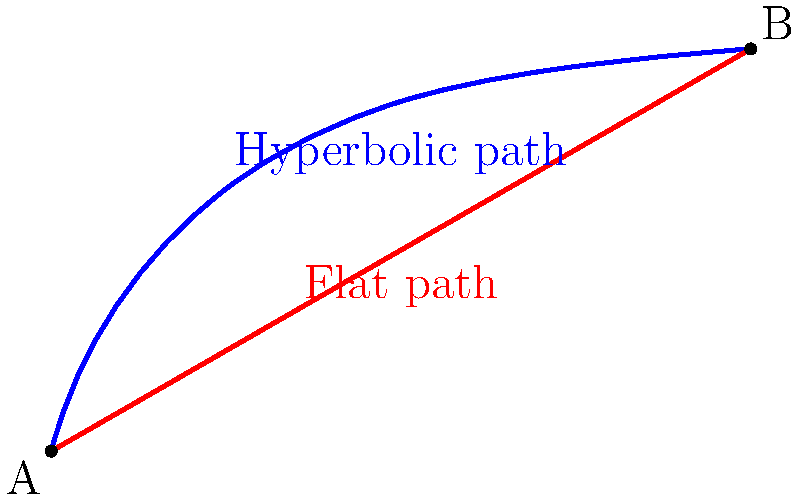In the context of content distribution strategies, consider two paths between points A and B: a hyperbolic path (blue) representing a non-linear content strategy, and a straight line (red) representing a traditional linear approach. If the hyperbolic path is 20% longer than the straight line, but enables reaching 50% more audience, what is the relative efficiency gain of the hyperbolic strategy in terms of audience reached per unit length compared to the linear strategy? To solve this problem, let's follow these steps:

1) Let's assume the length of the straight line (linear strategy) is $x$.

2) The hyperbolic path (non-linear strategy) is 20% longer, so its length is $1.2x$.

3) The audience reached by the linear strategy can be represented as $y$.

4) The non-linear strategy reaches 50% more audience, so it reaches $1.5y$.

5) Efficiency can be calculated as audience reached per unit length.

6) For the linear strategy:
   Efficiency = $\frac{y}{x}$

7) For the non-linear strategy:
   Efficiency = $\frac{1.5y}{1.2x}$ = $\frac{1.25y}{x}$

8) To find the relative efficiency gain, we divide the non-linear efficiency by the linear efficiency:

   $\frac{\text{Non-linear Efficiency}}{\text{Linear Efficiency}} = \frac{1.25y/x}{y/x} = 1.25$

9) This means the non-linear strategy is 1.25 times as efficient, or 25% more efficient.

10) To express this as a percentage gain: $(1.25 - 1) \times 100\% = 25\%$
Answer: 25% efficiency gain 